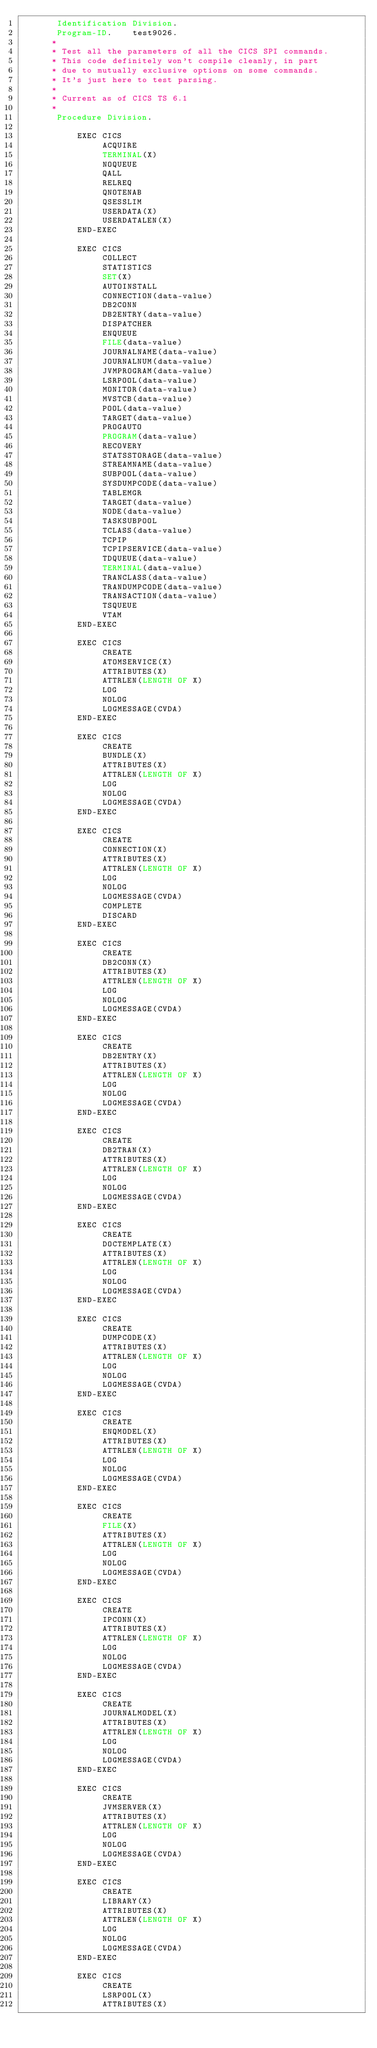Convert code to text. <code><loc_0><loc_0><loc_500><loc_500><_COBOL_>       Identification Division.
       Program-ID.    test9026.
      *
      * Test all the parameters of all the CICS SPI commands.
      * This code definitely won't compile cleanly, in part
      * due to mutually exclusive options on some commands.
      * It's just here to test parsing.
      *
      * Current as of CICS TS 6.1
      *
       Procedure Division.

           EXEC CICS
                ACQUIRE
                TERMINAL(X)
                NOQUEUE
                QALL
                RELREQ
                QNOTENAB
                QSESSLIM
                USERDATA(X)
                USERDATALEN(X)
           END-EXEC

           EXEC CICS
                COLLECT
                STATISTICS
                SET(X)
                AUTOINSTALL 
                CONNECTION(data-value)
                DB2CONN 
                DB2ENTRY(data-value)
                DISPATCHER 
                ENQUEUE 
                FILE(data-value)
                JOURNALNAME(data-value)
                JOURNALNUM(data-value)
                JVMPROGRAM(data-value)
                LSRPOOL(data-value)
                MONITOR(data-value)
                MVSTCB(data-value)
                POOL(data-value)
                TARGET(data-value)
                PROGAUTO 
                PROGRAM(data-value)
                RECOVERY 
                STATSSTORAGE(data-value)
                STREAMNAME(data-value)
                SUBPOOL(data-value)
                SYSDUMPCODE(data-value)
                TABLEMGR 
                TARGET(data-value)
                NODE(data-value)
                TASKSUBPOOL
                TCLASS(data-value)
                TCPIP
                TCPIPSERVICE(data-value)
                TDQUEUE(data-value)
                TERMINAL(data-value)
                TRANCLASS(data-value)
                TRANDUMPCODE(data-value)
                TRANSACTION(data-value)
                TSQUEUE
                VTAM
           END-EXEC

           EXEC CICS
                CREATE
                ATOMSERVICE(X)
                ATTRIBUTES(X)
                ATTRLEN(LENGTH OF X)
                LOG
                NOLOG
                LOGMESSAGE(CVDA)
           END-EXEC

           EXEC CICS
                CREATE
                BUNDLE(X)
                ATTRIBUTES(X)
                ATTRLEN(LENGTH OF X)
                LOG
                NOLOG
                LOGMESSAGE(CVDA)
           END-EXEC

           EXEC CICS
                CREATE
                CONNECTION(X)
                ATTRIBUTES(X)
                ATTRLEN(LENGTH OF X)
                LOG
                NOLOG
                LOGMESSAGE(CVDA)
                COMPLETE
                DISCARD
           END-EXEC

           EXEC CICS
                CREATE
                DB2CONN(X)
                ATTRIBUTES(X)
                ATTRLEN(LENGTH OF X)
                LOG
                NOLOG
                LOGMESSAGE(CVDA)
           END-EXEC

           EXEC CICS
                CREATE
                DB2ENTRY(X)
                ATTRIBUTES(X)
                ATTRLEN(LENGTH OF X)
                LOG
                NOLOG
                LOGMESSAGE(CVDA)
           END-EXEC

           EXEC CICS
                CREATE
                DB2TRAN(X)
                ATTRIBUTES(X)
                ATTRLEN(LENGTH OF X)
                LOG
                NOLOG
                LOGMESSAGE(CVDA)
           END-EXEC

           EXEC CICS
                CREATE
                DOCTEMPLATE(X)
                ATTRIBUTES(X)
                ATTRLEN(LENGTH OF X)
                LOG
                NOLOG
                LOGMESSAGE(CVDA)
           END-EXEC

           EXEC CICS
                CREATE
                DUMPCODE(X)
                ATTRIBUTES(X)
                ATTRLEN(LENGTH OF X)
                LOG
                NOLOG
                LOGMESSAGE(CVDA)
           END-EXEC

           EXEC CICS
                CREATE
                ENQMODEL(X)
                ATTRIBUTES(X)
                ATTRLEN(LENGTH OF X)
                LOG
                NOLOG
                LOGMESSAGE(CVDA)
           END-EXEC

           EXEC CICS
                CREATE
                FILE(X)
                ATTRIBUTES(X)
                ATTRLEN(LENGTH OF X)
                LOG
                NOLOG
                LOGMESSAGE(CVDA)
           END-EXEC

           EXEC CICS
                CREATE
                IPCONN(X)
                ATTRIBUTES(X)
                ATTRLEN(LENGTH OF X)
                LOG
                NOLOG
                LOGMESSAGE(CVDA)
           END-EXEC

           EXEC CICS
                CREATE
                JOURNALMODEL(X)
                ATTRIBUTES(X)
                ATTRLEN(LENGTH OF X)
                LOG
                NOLOG
                LOGMESSAGE(CVDA)
           END-EXEC

           EXEC CICS
                CREATE
                JVMSERVER(X)
                ATTRIBUTES(X)
                ATTRLEN(LENGTH OF X)
                LOG
                NOLOG
                LOGMESSAGE(CVDA)
           END-EXEC

           EXEC CICS
                CREATE
                LIBRARY(X)
                ATTRIBUTES(X)
                ATTRLEN(LENGTH OF X)
                LOG
                NOLOG
                LOGMESSAGE(CVDA)
           END-EXEC

           EXEC CICS
                CREATE
                LSRPOOL(X)
                ATTRIBUTES(X)</code> 